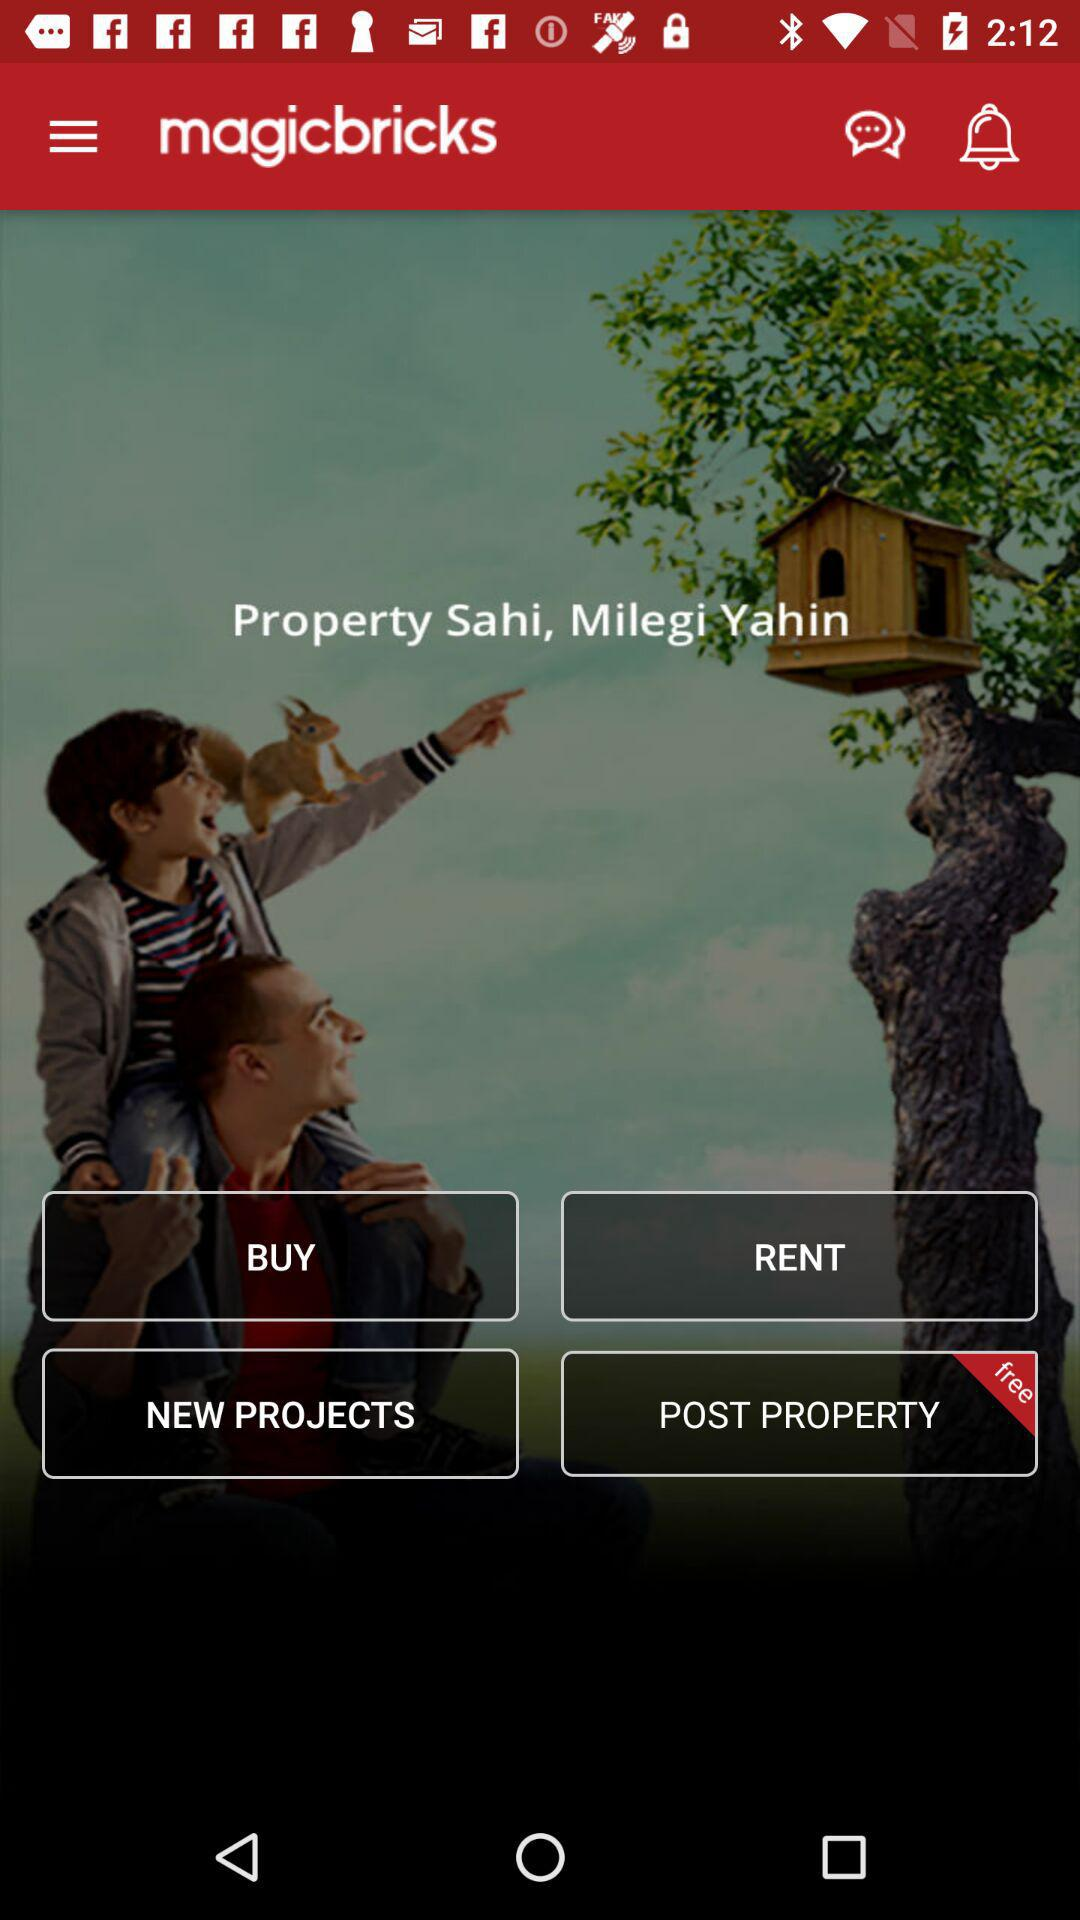What is the application name? The application name is "magicbricks". 